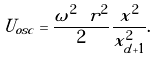Convert formula to latex. <formula><loc_0><loc_0><loc_500><loc_500>U _ { o s c } = \frac { \omega ^ { 2 } \ r ^ { 2 } } { 2 } \frac { { x } ^ { 2 } } { { x } ^ { 2 } _ { d + 1 } } .</formula> 